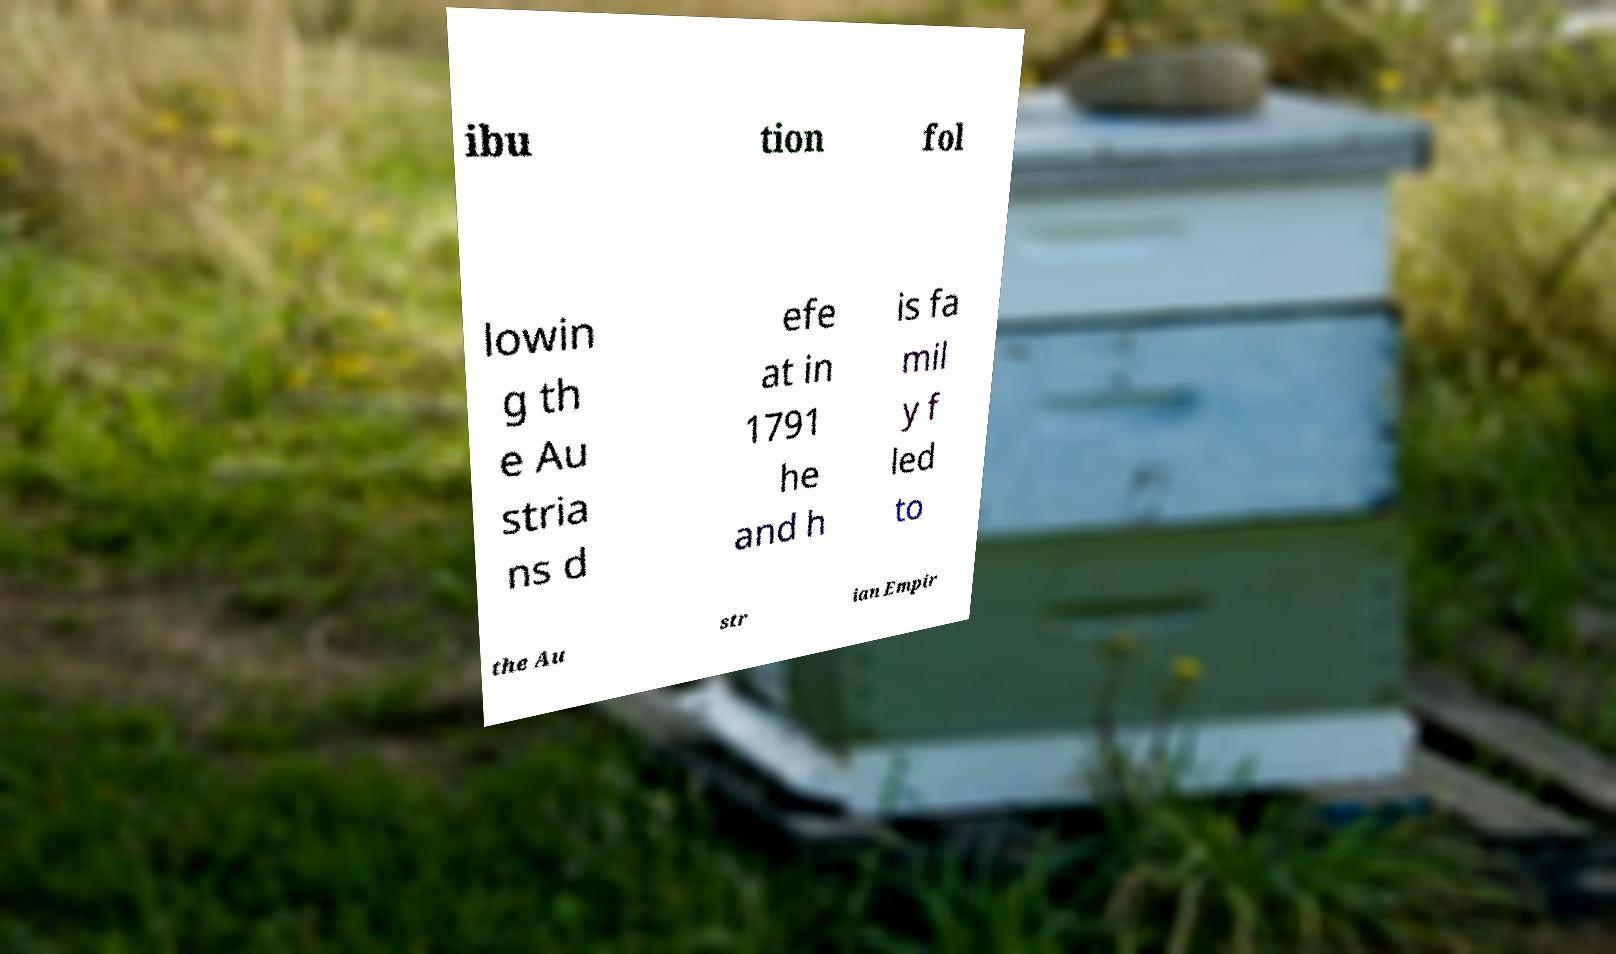For documentation purposes, I need the text within this image transcribed. Could you provide that? ibu tion fol lowin g th e Au stria ns d efe at in 1791 he and h is fa mil y f led to the Au str ian Empir 